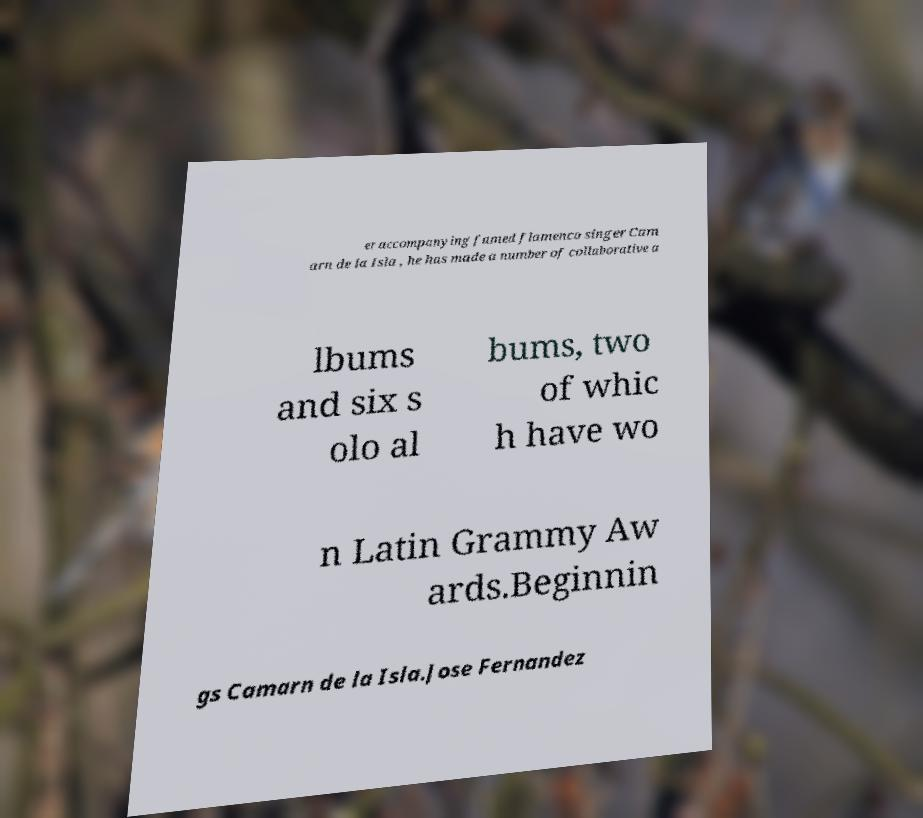There's text embedded in this image that I need extracted. Can you transcribe it verbatim? er accompanying famed flamenco singer Cam arn de la Isla , he has made a number of collaborative a lbums and six s olo al bums, two of whic h have wo n Latin Grammy Aw ards.Beginnin gs Camarn de la Isla.Jose Fernandez 